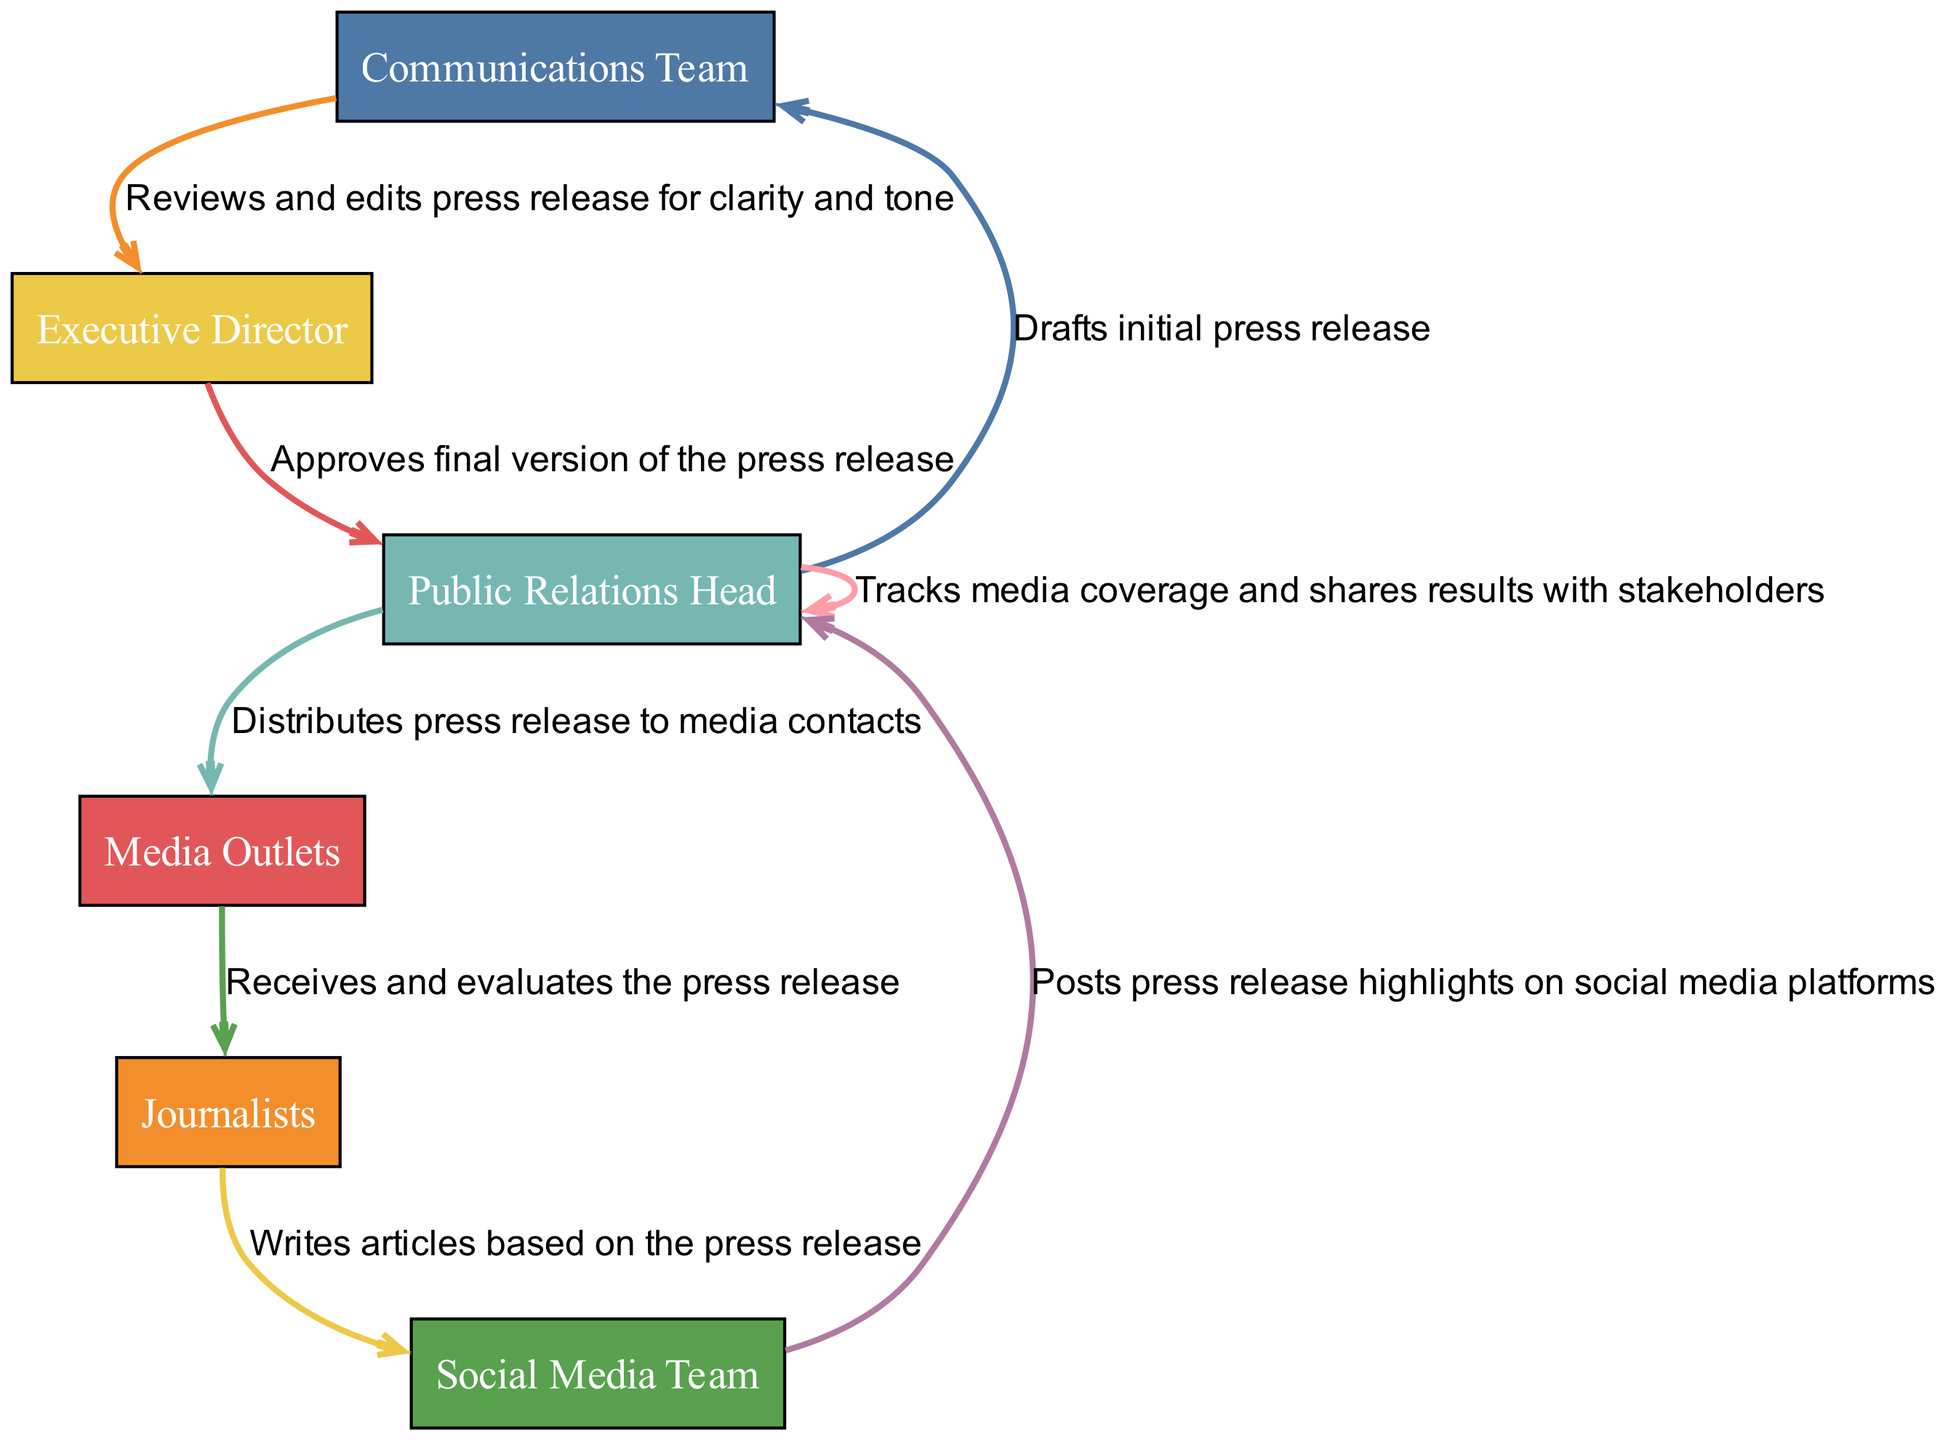What is the first action in the sequence? The first action in the sequence diagram is performed by the Public Relations Head, who drafts the initial press release. This is confirmed by the first element listed in the sequence.
Answer: Drafts initial press release Who reviews the press release? The review of the press release is conducted by the Communications Team, as indicated in the second action of the sequence diagram.
Answer: Communications Team How many distinct actors are involved in the sequence? There are a total of 8 distinct actors participating in the sequence of actions, as identified through reviewing each unique actor in the sequenceElements list.
Answer: 8 What action follows the distribution of the press release? After the Public Relations Head distributes the press release, the next action taken is by Media Outlets, who receive and evaluate the press release. This can be traced directly in the order of actions provided.
Answer: Receives and evaluates the press release Which actor is responsible for tracking media coverage? The responsibility for tracking media coverage lies with the Public Relations Head, as shown in the last action of the sequence diagram.
Answer: Public Relations Head Why does the Public Relations Head track media coverage at the end of the sequence? The Public Relations Head tracks media coverage after distributing the press release to understand its impact and effectiveness, and to share the results with stakeholders. This is inferred from the logical flow of actions in the sequence where tracking occurs at the final stage after distribution.
Answer: To share results with stakeholders Which two actors are involved in the final two actions of the sequence? The last two actions are performed by the Media Outlets, who evaluate the press release, followed by the journalists, who write articles based on the information. This can be confirmed by looking at the last two elements in the sequence.
Answer: Media Outlets and Journalists What is the total number of actions in the sequence? The sequence contains a total of 8 distinct actions listed in the sequenceElements, where each action correlates to an actor's responsibility throughout the press release process.
Answer: 8 